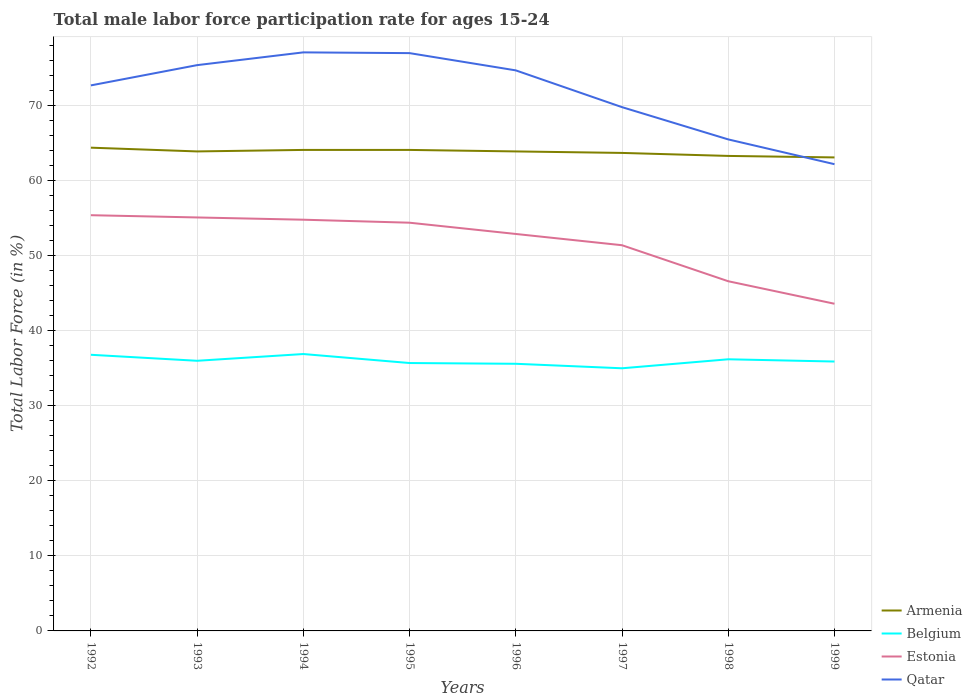Is the number of lines equal to the number of legend labels?
Your answer should be very brief. Yes. Across all years, what is the maximum male labor force participation rate in Armenia?
Your response must be concise. 63.1. In which year was the male labor force participation rate in Armenia maximum?
Offer a terse response. 1999. What is the total male labor force participation rate in Armenia in the graph?
Ensure brevity in your answer.  1. What is the difference between the highest and the second highest male labor force participation rate in Estonia?
Make the answer very short. 11.8. What is the difference between the highest and the lowest male labor force participation rate in Belgium?
Give a very brief answer. 3. Is the male labor force participation rate in Estonia strictly greater than the male labor force participation rate in Armenia over the years?
Offer a very short reply. Yes. What is the difference between two consecutive major ticks on the Y-axis?
Offer a terse response. 10. Are the values on the major ticks of Y-axis written in scientific E-notation?
Give a very brief answer. No. Where does the legend appear in the graph?
Provide a succinct answer. Bottom right. How many legend labels are there?
Provide a short and direct response. 4. How are the legend labels stacked?
Your answer should be very brief. Vertical. What is the title of the graph?
Make the answer very short. Total male labor force participation rate for ages 15-24. Does "United Kingdom" appear as one of the legend labels in the graph?
Keep it short and to the point. No. What is the label or title of the X-axis?
Offer a very short reply. Years. What is the label or title of the Y-axis?
Your answer should be compact. Total Labor Force (in %). What is the Total Labor Force (in %) in Armenia in 1992?
Your answer should be compact. 64.4. What is the Total Labor Force (in %) in Belgium in 1992?
Provide a succinct answer. 36.8. What is the Total Labor Force (in %) in Estonia in 1992?
Provide a succinct answer. 55.4. What is the Total Labor Force (in %) in Qatar in 1992?
Your answer should be very brief. 72.7. What is the Total Labor Force (in %) of Armenia in 1993?
Ensure brevity in your answer.  63.9. What is the Total Labor Force (in %) in Estonia in 1993?
Ensure brevity in your answer.  55.1. What is the Total Labor Force (in %) in Qatar in 1993?
Give a very brief answer. 75.4. What is the Total Labor Force (in %) in Armenia in 1994?
Offer a terse response. 64.1. What is the Total Labor Force (in %) of Belgium in 1994?
Your response must be concise. 36.9. What is the Total Labor Force (in %) of Estonia in 1994?
Give a very brief answer. 54.8. What is the Total Labor Force (in %) in Qatar in 1994?
Provide a succinct answer. 77.1. What is the Total Labor Force (in %) of Armenia in 1995?
Keep it short and to the point. 64.1. What is the Total Labor Force (in %) of Belgium in 1995?
Your response must be concise. 35.7. What is the Total Labor Force (in %) in Estonia in 1995?
Provide a succinct answer. 54.4. What is the Total Labor Force (in %) of Armenia in 1996?
Your answer should be very brief. 63.9. What is the Total Labor Force (in %) in Belgium in 1996?
Your answer should be very brief. 35.6. What is the Total Labor Force (in %) of Estonia in 1996?
Make the answer very short. 52.9. What is the Total Labor Force (in %) of Qatar in 1996?
Provide a short and direct response. 74.7. What is the Total Labor Force (in %) in Armenia in 1997?
Your answer should be compact. 63.7. What is the Total Labor Force (in %) of Belgium in 1997?
Your answer should be compact. 35. What is the Total Labor Force (in %) of Estonia in 1997?
Provide a succinct answer. 51.4. What is the Total Labor Force (in %) in Qatar in 1997?
Offer a terse response. 69.8. What is the Total Labor Force (in %) of Armenia in 1998?
Offer a terse response. 63.3. What is the Total Labor Force (in %) in Belgium in 1998?
Make the answer very short. 36.2. What is the Total Labor Force (in %) in Estonia in 1998?
Ensure brevity in your answer.  46.6. What is the Total Labor Force (in %) in Qatar in 1998?
Provide a succinct answer. 65.5. What is the Total Labor Force (in %) in Armenia in 1999?
Offer a terse response. 63.1. What is the Total Labor Force (in %) in Belgium in 1999?
Offer a very short reply. 35.9. What is the Total Labor Force (in %) in Estonia in 1999?
Keep it short and to the point. 43.6. What is the Total Labor Force (in %) of Qatar in 1999?
Your response must be concise. 62.2. Across all years, what is the maximum Total Labor Force (in %) in Armenia?
Your answer should be compact. 64.4. Across all years, what is the maximum Total Labor Force (in %) in Belgium?
Provide a succinct answer. 36.9. Across all years, what is the maximum Total Labor Force (in %) of Estonia?
Offer a terse response. 55.4. Across all years, what is the maximum Total Labor Force (in %) in Qatar?
Provide a succinct answer. 77.1. Across all years, what is the minimum Total Labor Force (in %) in Armenia?
Provide a short and direct response. 63.1. Across all years, what is the minimum Total Labor Force (in %) of Belgium?
Provide a succinct answer. 35. Across all years, what is the minimum Total Labor Force (in %) of Estonia?
Make the answer very short. 43.6. Across all years, what is the minimum Total Labor Force (in %) of Qatar?
Your response must be concise. 62.2. What is the total Total Labor Force (in %) in Armenia in the graph?
Make the answer very short. 510.5. What is the total Total Labor Force (in %) in Belgium in the graph?
Your answer should be compact. 288.1. What is the total Total Labor Force (in %) in Estonia in the graph?
Offer a very short reply. 414.2. What is the total Total Labor Force (in %) of Qatar in the graph?
Your response must be concise. 574.4. What is the difference between the Total Labor Force (in %) of Armenia in 1992 and that in 1993?
Your answer should be compact. 0.5. What is the difference between the Total Labor Force (in %) in Estonia in 1992 and that in 1993?
Offer a very short reply. 0.3. What is the difference between the Total Labor Force (in %) in Qatar in 1992 and that in 1993?
Offer a terse response. -2.7. What is the difference between the Total Labor Force (in %) in Qatar in 1992 and that in 1994?
Ensure brevity in your answer.  -4.4. What is the difference between the Total Labor Force (in %) of Estonia in 1992 and that in 1995?
Give a very brief answer. 1. What is the difference between the Total Labor Force (in %) of Belgium in 1992 and that in 1996?
Your answer should be very brief. 1.2. What is the difference between the Total Labor Force (in %) in Armenia in 1992 and that in 1997?
Offer a terse response. 0.7. What is the difference between the Total Labor Force (in %) in Belgium in 1992 and that in 1997?
Provide a succinct answer. 1.8. What is the difference between the Total Labor Force (in %) in Estonia in 1992 and that in 1997?
Give a very brief answer. 4. What is the difference between the Total Labor Force (in %) of Armenia in 1992 and that in 1998?
Your response must be concise. 1.1. What is the difference between the Total Labor Force (in %) of Belgium in 1992 and that in 1998?
Provide a short and direct response. 0.6. What is the difference between the Total Labor Force (in %) of Estonia in 1992 and that in 1998?
Offer a terse response. 8.8. What is the difference between the Total Labor Force (in %) of Qatar in 1992 and that in 1998?
Keep it short and to the point. 7.2. What is the difference between the Total Labor Force (in %) in Armenia in 1992 and that in 1999?
Your answer should be very brief. 1.3. What is the difference between the Total Labor Force (in %) of Belgium in 1992 and that in 1999?
Give a very brief answer. 0.9. What is the difference between the Total Labor Force (in %) in Estonia in 1992 and that in 1999?
Your answer should be very brief. 11.8. What is the difference between the Total Labor Force (in %) in Belgium in 1993 and that in 1994?
Give a very brief answer. -0.9. What is the difference between the Total Labor Force (in %) in Estonia in 1993 and that in 1994?
Offer a terse response. 0.3. What is the difference between the Total Labor Force (in %) of Armenia in 1993 and that in 1995?
Your answer should be very brief. -0.2. What is the difference between the Total Labor Force (in %) of Estonia in 1993 and that in 1995?
Give a very brief answer. 0.7. What is the difference between the Total Labor Force (in %) of Qatar in 1993 and that in 1995?
Ensure brevity in your answer.  -1.6. What is the difference between the Total Labor Force (in %) of Belgium in 1993 and that in 1996?
Ensure brevity in your answer.  0.4. What is the difference between the Total Labor Force (in %) in Estonia in 1993 and that in 1996?
Give a very brief answer. 2.2. What is the difference between the Total Labor Force (in %) in Estonia in 1993 and that in 1997?
Keep it short and to the point. 3.7. What is the difference between the Total Labor Force (in %) in Belgium in 1993 and that in 1998?
Your response must be concise. -0.2. What is the difference between the Total Labor Force (in %) of Estonia in 1993 and that in 1998?
Your answer should be compact. 8.5. What is the difference between the Total Labor Force (in %) in Qatar in 1993 and that in 1998?
Keep it short and to the point. 9.9. What is the difference between the Total Labor Force (in %) in Armenia in 1993 and that in 1999?
Give a very brief answer. 0.8. What is the difference between the Total Labor Force (in %) in Armenia in 1994 and that in 1995?
Keep it short and to the point. 0. What is the difference between the Total Labor Force (in %) in Armenia in 1994 and that in 1996?
Offer a very short reply. 0.2. What is the difference between the Total Labor Force (in %) in Estonia in 1994 and that in 1996?
Ensure brevity in your answer.  1.9. What is the difference between the Total Labor Force (in %) in Estonia in 1994 and that in 1997?
Provide a succinct answer. 3.4. What is the difference between the Total Labor Force (in %) in Qatar in 1994 and that in 1997?
Give a very brief answer. 7.3. What is the difference between the Total Labor Force (in %) of Armenia in 1994 and that in 1998?
Offer a terse response. 0.8. What is the difference between the Total Labor Force (in %) in Armenia in 1994 and that in 1999?
Ensure brevity in your answer.  1. What is the difference between the Total Labor Force (in %) of Estonia in 1994 and that in 1999?
Your answer should be very brief. 11.2. What is the difference between the Total Labor Force (in %) of Belgium in 1995 and that in 1996?
Make the answer very short. 0.1. What is the difference between the Total Labor Force (in %) of Armenia in 1995 and that in 1997?
Offer a very short reply. 0.4. What is the difference between the Total Labor Force (in %) of Estonia in 1995 and that in 1997?
Keep it short and to the point. 3. What is the difference between the Total Labor Force (in %) of Armenia in 1995 and that in 1998?
Ensure brevity in your answer.  0.8. What is the difference between the Total Labor Force (in %) in Belgium in 1995 and that in 1998?
Provide a short and direct response. -0.5. What is the difference between the Total Labor Force (in %) in Estonia in 1995 and that in 1998?
Ensure brevity in your answer.  7.8. What is the difference between the Total Labor Force (in %) of Armenia in 1995 and that in 1999?
Provide a short and direct response. 1. What is the difference between the Total Labor Force (in %) in Estonia in 1995 and that in 1999?
Provide a succinct answer. 10.8. What is the difference between the Total Labor Force (in %) of Armenia in 1996 and that in 1997?
Offer a terse response. 0.2. What is the difference between the Total Labor Force (in %) of Estonia in 1996 and that in 1997?
Make the answer very short. 1.5. What is the difference between the Total Labor Force (in %) of Armenia in 1996 and that in 1998?
Ensure brevity in your answer.  0.6. What is the difference between the Total Labor Force (in %) in Belgium in 1996 and that in 1998?
Offer a very short reply. -0.6. What is the difference between the Total Labor Force (in %) in Armenia in 1996 and that in 1999?
Ensure brevity in your answer.  0.8. What is the difference between the Total Labor Force (in %) in Qatar in 1997 and that in 1998?
Provide a short and direct response. 4.3. What is the difference between the Total Labor Force (in %) of Armenia in 1997 and that in 1999?
Give a very brief answer. 0.6. What is the difference between the Total Labor Force (in %) of Belgium in 1997 and that in 1999?
Offer a very short reply. -0.9. What is the difference between the Total Labor Force (in %) in Qatar in 1997 and that in 1999?
Your response must be concise. 7.6. What is the difference between the Total Labor Force (in %) of Estonia in 1998 and that in 1999?
Provide a succinct answer. 3. What is the difference between the Total Labor Force (in %) of Armenia in 1992 and the Total Labor Force (in %) of Belgium in 1993?
Provide a short and direct response. 28.4. What is the difference between the Total Labor Force (in %) in Belgium in 1992 and the Total Labor Force (in %) in Estonia in 1993?
Your answer should be very brief. -18.3. What is the difference between the Total Labor Force (in %) in Belgium in 1992 and the Total Labor Force (in %) in Qatar in 1993?
Your response must be concise. -38.6. What is the difference between the Total Labor Force (in %) in Estonia in 1992 and the Total Labor Force (in %) in Qatar in 1993?
Your response must be concise. -20. What is the difference between the Total Labor Force (in %) of Armenia in 1992 and the Total Labor Force (in %) of Estonia in 1994?
Your answer should be compact. 9.6. What is the difference between the Total Labor Force (in %) of Armenia in 1992 and the Total Labor Force (in %) of Qatar in 1994?
Ensure brevity in your answer.  -12.7. What is the difference between the Total Labor Force (in %) in Belgium in 1992 and the Total Labor Force (in %) in Estonia in 1994?
Your answer should be very brief. -18. What is the difference between the Total Labor Force (in %) in Belgium in 1992 and the Total Labor Force (in %) in Qatar in 1994?
Make the answer very short. -40.3. What is the difference between the Total Labor Force (in %) of Estonia in 1992 and the Total Labor Force (in %) of Qatar in 1994?
Give a very brief answer. -21.7. What is the difference between the Total Labor Force (in %) of Armenia in 1992 and the Total Labor Force (in %) of Belgium in 1995?
Provide a succinct answer. 28.7. What is the difference between the Total Labor Force (in %) in Armenia in 1992 and the Total Labor Force (in %) in Estonia in 1995?
Your answer should be very brief. 10. What is the difference between the Total Labor Force (in %) in Belgium in 1992 and the Total Labor Force (in %) in Estonia in 1995?
Your response must be concise. -17.6. What is the difference between the Total Labor Force (in %) in Belgium in 1992 and the Total Labor Force (in %) in Qatar in 1995?
Ensure brevity in your answer.  -40.2. What is the difference between the Total Labor Force (in %) in Estonia in 1992 and the Total Labor Force (in %) in Qatar in 1995?
Provide a short and direct response. -21.6. What is the difference between the Total Labor Force (in %) in Armenia in 1992 and the Total Labor Force (in %) in Belgium in 1996?
Your response must be concise. 28.8. What is the difference between the Total Labor Force (in %) of Armenia in 1992 and the Total Labor Force (in %) of Qatar in 1996?
Ensure brevity in your answer.  -10.3. What is the difference between the Total Labor Force (in %) in Belgium in 1992 and the Total Labor Force (in %) in Estonia in 1996?
Provide a short and direct response. -16.1. What is the difference between the Total Labor Force (in %) of Belgium in 1992 and the Total Labor Force (in %) of Qatar in 1996?
Your response must be concise. -37.9. What is the difference between the Total Labor Force (in %) in Estonia in 1992 and the Total Labor Force (in %) in Qatar in 1996?
Make the answer very short. -19.3. What is the difference between the Total Labor Force (in %) in Armenia in 1992 and the Total Labor Force (in %) in Belgium in 1997?
Keep it short and to the point. 29.4. What is the difference between the Total Labor Force (in %) of Armenia in 1992 and the Total Labor Force (in %) of Qatar in 1997?
Your response must be concise. -5.4. What is the difference between the Total Labor Force (in %) in Belgium in 1992 and the Total Labor Force (in %) in Estonia in 1997?
Offer a terse response. -14.6. What is the difference between the Total Labor Force (in %) of Belgium in 1992 and the Total Labor Force (in %) of Qatar in 1997?
Keep it short and to the point. -33. What is the difference between the Total Labor Force (in %) in Estonia in 1992 and the Total Labor Force (in %) in Qatar in 1997?
Provide a short and direct response. -14.4. What is the difference between the Total Labor Force (in %) of Armenia in 1992 and the Total Labor Force (in %) of Belgium in 1998?
Provide a short and direct response. 28.2. What is the difference between the Total Labor Force (in %) of Armenia in 1992 and the Total Labor Force (in %) of Estonia in 1998?
Your response must be concise. 17.8. What is the difference between the Total Labor Force (in %) of Belgium in 1992 and the Total Labor Force (in %) of Qatar in 1998?
Your response must be concise. -28.7. What is the difference between the Total Labor Force (in %) in Estonia in 1992 and the Total Labor Force (in %) in Qatar in 1998?
Your answer should be very brief. -10.1. What is the difference between the Total Labor Force (in %) of Armenia in 1992 and the Total Labor Force (in %) of Estonia in 1999?
Your answer should be very brief. 20.8. What is the difference between the Total Labor Force (in %) in Belgium in 1992 and the Total Labor Force (in %) in Estonia in 1999?
Your response must be concise. -6.8. What is the difference between the Total Labor Force (in %) in Belgium in 1992 and the Total Labor Force (in %) in Qatar in 1999?
Provide a succinct answer. -25.4. What is the difference between the Total Labor Force (in %) in Armenia in 1993 and the Total Labor Force (in %) in Estonia in 1994?
Give a very brief answer. 9.1. What is the difference between the Total Labor Force (in %) of Belgium in 1993 and the Total Labor Force (in %) of Estonia in 1994?
Make the answer very short. -18.8. What is the difference between the Total Labor Force (in %) of Belgium in 1993 and the Total Labor Force (in %) of Qatar in 1994?
Provide a succinct answer. -41.1. What is the difference between the Total Labor Force (in %) in Armenia in 1993 and the Total Labor Force (in %) in Belgium in 1995?
Provide a short and direct response. 28.2. What is the difference between the Total Labor Force (in %) of Belgium in 1993 and the Total Labor Force (in %) of Estonia in 1995?
Offer a very short reply. -18.4. What is the difference between the Total Labor Force (in %) in Belgium in 1993 and the Total Labor Force (in %) in Qatar in 1995?
Ensure brevity in your answer.  -41. What is the difference between the Total Labor Force (in %) in Estonia in 1993 and the Total Labor Force (in %) in Qatar in 1995?
Your response must be concise. -21.9. What is the difference between the Total Labor Force (in %) in Armenia in 1993 and the Total Labor Force (in %) in Belgium in 1996?
Offer a terse response. 28.3. What is the difference between the Total Labor Force (in %) of Belgium in 1993 and the Total Labor Force (in %) of Estonia in 1996?
Your answer should be very brief. -16.9. What is the difference between the Total Labor Force (in %) in Belgium in 1993 and the Total Labor Force (in %) in Qatar in 1996?
Make the answer very short. -38.7. What is the difference between the Total Labor Force (in %) of Estonia in 1993 and the Total Labor Force (in %) of Qatar in 1996?
Ensure brevity in your answer.  -19.6. What is the difference between the Total Labor Force (in %) of Armenia in 1993 and the Total Labor Force (in %) of Belgium in 1997?
Offer a very short reply. 28.9. What is the difference between the Total Labor Force (in %) of Belgium in 1993 and the Total Labor Force (in %) of Estonia in 1997?
Offer a very short reply. -15.4. What is the difference between the Total Labor Force (in %) of Belgium in 1993 and the Total Labor Force (in %) of Qatar in 1997?
Provide a short and direct response. -33.8. What is the difference between the Total Labor Force (in %) of Estonia in 1993 and the Total Labor Force (in %) of Qatar in 1997?
Give a very brief answer. -14.7. What is the difference between the Total Labor Force (in %) in Armenia in 1993 and the Total Labor Force (in %) in Belgium in 1998?
Your answer should be compact. 27.7. What is the difference between the Total Labor Force (in %) of Armenia in 1993 and the Total Labor Force (in %) of Estonia in 1998?
Keep it short and to the point. 17.3. What is the difference between the Total Labor Force (in %) of Belgium in 1993 and the Total Labor Force (in %) of Qatar in 1998?
Offer a terse response. -29.5. What is the difference between the Total Labor Force (in %) of Estonia in 1993 and the Total Labor Force (in %) of Qatar in 1998?
Provide a short and direct response. -10.4. What is the difference between the Total Labor Force (in %) of Armenia in 1993 and the Total Labor Force (in %) of Estonia in 1999?
Provide a short and direct response. 20.3. What is the difference between the Total Labor Force (in %) in Armenia in 1993 and the Total Labor Force (in %) in Qatar in 1999?
Provide a short and direct response. 1.7. What is the difference between the Total Labor Force (in %) of Belgium in 1993 and the Total Labor Force (in %) of Qatar in 1999?
Provide a succinct answer. -26.2. What is the difference between the Total Labor Force (in %) in Estonia in 1993 and the Total Labor Force (in %) in Qatar in 1999?
Provide a short and direct response. -7.1. What is the difference between the Total Labor Force (in %) in Armenia in 1994 and the Total Labor Force (in %) in Belgium in 1995?
Your response must be concise. 28.4. What is the difference between the Total Labor Force (in %) of Armenia in 1994 and the Total Labor Force (in %) of Qatar in 1995?
Your response must be concise. -12.9. What is the difference between the Total Labor Force (in %) of Belgium in 1994 and the Total Labor Force (in %) of Estonia in 1995?
Offer a terse response. -17.5. What is the difference between the Total Labor Force (in %) in Belgium in 1994 and the Total Labor Force (in %) in Qatar in 1995?
Keep it short and to the point. -40.1. What is the difference between the Total Labor Force (in %) of Estonia in 1994 and the Total Labor Force (in %) of Qatar in 1995?
Provide a short and direct response. -22.2. What is the difference between the Total Labor Force (in %) in Armenia in 1994 and the Total Labor Force (in %) in Estonia in 1996?
Your response must be concise. 11.2. What is the difference between the Total Labor Force (in %) in Armenia in 1994 and the Total Labor Force (in %) in Qatar in 1996?
Offer a terse response. -10.6. What is the difference between the Total Labor Force (in %) of Belgium in 1994 and the Total Labor Force (in %) of Qatar in 1996?
Give a very brief answer. -37.8. What is the difference between the Total Labor Force (in %) in Estonia in 1994 and the Total Labor Force (in %) in Qatar in 1996?
Make the answer very short. -19.9. What is the difference between the Total Labor Force (in %) of Armenia in 1994 and the Total Labor Force (in %) of Belgium in 1997?
Offer a terse response. 29.1. What is the difference between the Total Labor Force (in %) of Armenia in 1994 and the Total Labor Force (in %) of Estonia in 1997?
Provide a short and direct response. 12.7. What is the difference between the Total Labor Force (in %) in Armenia in 1994 and the Total Labor Force (in %) in Qatar in 1997?
Provide a succinct answer. -5.7. What is the difference between the Total Labor Force (in %) in Belgium in 1994 and the Total Labor Force (in %) in Qatar in 1997?
Ensure brevity in your answer.  -32.9. What is the difference between the Total Labor Force (in %) in Estonia in 1994 and the Total Labor Force (in %) in Qatar in 1997?
Provide a short and direct response. -15. What is the difference between the Total Labor Force (in %) in Armenia in 1994 and the Total Labor Force (in %) in Belgium in 1998?
Ensure brevity in your answer.  27.9. What is the difference between the Total Labor Force (in %) of Armenia in 1994 and the Total Labor Force (in %) of Estonia in 1998?
Keep it short and to the point. 17.5. What is the difference between the Total Labor Force (in %) of Armenia in 1994 and the Total Labor Force (in %) of Qatar in 1998?
Ensure brevity in your answer.  -1.4. What is the difference between the Total Labor Force (in %) in Belgium in 1994 and the Total Labor Force (in %) in Qatar in 1998?
Your response must be concise. -28.6. What is the difference between the Total Labor Force (in %) of Armenia in 1994 and the Total Labor Force (in %) of Belgium in 1999?
Offer a terse response. 28.2. What is the difference between the Total Labor Force (in %) of Armenia in 1994 and the Total Labor Force (in %) of Qatar in 1999?
Make the answer very short. 1.9. What is the difference between the Total Labor Force (in %) in Belgium in 1994 and the Total Labor Force (in %) in Estonia in 1999?
Your answer should be compact. -6.7. What is the difference between the Total Labor Force (in %) of Belgium in 1994 and the Total Labor Force (in %) of Qatar in 1999?
Give a very brief answer. -25.3. What is the difference between the Total Labor Force (in %) of Armenia in 1995 and the Total Labor Force (in %) of Belgium in 1996?
Your response must be concise. 28.5. What is the difference between the Total Labor Force (in %) in Armenia in 1995 and the Total Labor Force (in %) in Qatar in 1996?
Offer a very short reply. -10.6. What is the difference between the Total Labor Force (in %) of Belgium in 1995 and the Total Labor Force (in %) of Estonia in 1996?
Offer a terse response. -17.2. What is the difference between the Total Labor Force (in %) of Belgium in 1995 and the Total Labor Force (in %) of Qatar in 1996?
Offer a very short reply. -39. What is the difference between the Total Labor Force (in %) of Estonia in 1995 and the Total Labor Force (in %) of Qatar in 1996?
Make the answer very short. -20.3. What is the difference between the Total Labor Force (in %) of Armenia in 1995 and the Total Labor Force (in %) of Belgium in 1997?
Keep it short and to the point. 29.1. What is the difference between the Total Labor Force (in %) in Armenia in 1995 and the Total Labor Force (in %) in Estonia in 1997?
Keep it short and to the point. 12.7. What is the difference between the Total Labor Force (in %) in Belgium in 1995 and the Total Labor Force (in %) in Estonia in 1997?
Give a very brief answer. -15.7. What is the difference between the Total Labor Force (in %) of Belgium in 1995 and the Total Labor Force (in %) of Qatar in 1997?
Your answer should be compact. -34.1. What is the difference between the Total Labor Force (in %) in Estonia in 1995 and the Total Labor Force (in %) in Qatar in 1997?
Keep it short and to the point. -15.4. What is the difference between the Total Labor Force (in %) of Armenia in 1995 and the Total Labor Force (in %) of Belgium in 1998?
Give a very brief answer. 27.9. What is the difference between the Total Labor Force (in %) in Armenia in 1995 and the Total Labor Force (in %) in Qatar in 1998?
Ensure brevity in your answer.  -1.4. What is the difference between the Total Labor Force (in %) of Belgium in 1995 and the Total Labor Force (in %) of Estonia in 1998?
Your response must be concise. -10.9. What is the difference between the Total Labor Force (in %) in Belgium in 1995 and the Total Labor Force (in %) in Qatar in 1998?
Provide a succinct answer. -29.8. What is the difference between the Total Labor Force (in %) of Armenia in 1995 and the Total Labor Force (in %) of Belgium in 1999?
Offer a very short reply. 28.2. What is the difference between the Total Labor Force (in %) of Armenia in 1995 and the Total Labor Force (in %) of Estonia in 1999?
Make the answer very short. 20.5. What is the difference between the Total Labor Force (in %) in Belgium in 1995 and the Total Labor Force (in %) in Estonia in 1999?
Offer a very short reply. -7.9. What is the difference between the Total Labor Force (in %) in Belgium in 1995 and the Total Labor Force (in %) in Qatar in 1999?
Offer a very short reply. -26.5. What is the difference between the Total Labor Force (in %) in Armenia in 1996 and the Total Labor Force (in %) in Belgium in 1997?
Provide a short and direct response. 28.9. What is the difference between the Total Labor Force (in %) in Armenia in 1996 and the Total Labor Force (in %) in Estonia in 1997?
Your answer should be very brief. 12.5. What is the difference between the Total Labor Force (in %) of Belgium in 1996 and the Total Labor Force (in %) of Estonia in 1997?
Offer a very short reply. -15.8. What is the difference between the Total Labor Force (in %) of Belgium in 1996 and the Total Labor Force (in %) of Qatar in 1997?
Offer a very short reply. -34.2. What is the difference between the Total Labor Force (in %) in Estonia in 1996 and the Total Labor Force (in %) in Qatar in 1997?
Ensure brevity in your answer.  -16.9. What is the difference between the Total Labor Force (in %) in Armenia in 1996 and the Total Labor Force (in %) in Belgium in 1998?
Give a very brief answer. 27.7. What is the difference between the Total Labor Force (in %) in Armenia in 1996 and the Total Labor Force (in %) in Qatar in 1998?
Provide a short and direct response. -1.6. What is the difference between the Total Labor Force (in %) of Belgium in 1996 and the Total Labor Force (in %) of Qatar in 1998?
Your answer should be very brief. -29.9. What is the difference between the Total Labor Force (in %) in Armenia in 1996 and the Total Labor Force (in %) in Estonia in 1999?
Provide a succinct answer. 20.3. What is the difference between the Total Labor Force (in %) of Belgium in 1996 and the Total Labor Force (in %) of Qatar in 1999?
Provide a short and direct response. -26.6. What is the difference between the Total Labor Force (in %) in Armenia in 1997 and the Total Labor Force (in %) in Belgium in 1998?
Give a very brief answer. 27.5. What is the difference between the Total Labor Force (in %) in Armenia in 1997 and the Total Labor Force (in %) in Estonia in 1998?
Your response must be concise. 17.1. What is the difference between the Total Labor Force (in %) in Armenia in 1997 and the Total Labor Force (in %) in Qatar in 1998?
Your answer should be very brief. -1.8. What is the difference between the Total Labor Force (in %) of Belgium in 1997 and the Total Labor Force (in %) of Estonia in 1998?
Your answer should be very brief. -11.6. What is the difference between the Total Labor Force (in %) in Belgium in 1997 and the Total Labor Force (in %) in Qatar in 1998?
Make the answer very short. -30.5. What is the difference between the Total Labor Force (in %) in Estonia in 1997 and the Total Labor Force (in %) in Qatar in 1998?
Offer a terse response. -14.1. What is the difference between the Total Labor Force (in %) in Armenia in 1997 and the Total Labor Force (in %) in Belgium in 1999?
Your answer should be very brief. 27.8. What is the difference between the Total Labor Force (in %) in Armenia in 1997 and the Total Labor Force (in %) in Estonia in 1999?
Provide a short and direct response. 20.1. What is the difference between the Total Labor Force (in %) in Belgium in 1997 and the Total Labor Force (in %) in Qatar in 1999?
Make the answer very short. -27.2. What is the difference between the Total Labor Force (in %) of Estonia in 1997 and the Total Labor Force (in %) of Qatar in 1999?
Ensure brevity in your answer.  -10.8. What is the difference between the Total Labor Force (in %) in Armenia in 1998 and the Total Labor Force (in %) in Belgium in 1999?
Give a very brief answer. 27.4. What is the difference between the Total Labor Force (in %) of Armenia in 1998 and the Total Labor Force (in %) of Qatar in 1999?
Offer a terse response. 1.1. What is the difference between the Total Labor Force (in %) in Estonia in 1998 and the Total Labor Force (in %) in Qatar in 1999?
Your answer should be very brief. -15.6. What is the average Total Labor Force (in %) of Armenia per year?
Provide a succinct answer. 63.81. What is the average Total Labor Force (in %) in Belgium per year?
Keep it short and to the point. 36.01. What is the average Total Labor Force (in %) of Estonia per year?
Your answer should be very brief. 51.77. What is the average Total Labor Force (in %) in Qatar per year?
Your answer should be very brief. 71.8. In the year 1992, what is the difference between the Total Labor Force (in %) of Armenia and Total Labor Force (in %) of Belgium?
Offer a very short reply. 27.6. In the year 1992, what is the difference between the Total Labor Force (in %) in Belgium and Total Labor Force (in %) in Estonia?
Make the answer very short. -18.6. In the year 1992, what is the difference between the Total Labor Force (in %) in Belgium and Total Labor Force (in %) in Qatar?
Your answer should be very brief. -35.9. In the year 1992, what is the difference between the Total Labor Force (in %) of Estonia and Total Labor Force (in %) of Qatar?
Your answer should be very brief. -17.3. In the year 1993, what is the difference between the Total Labor Force (in %) in Armenia and Total Labor Force (in %) in Belgium?
Give a very brief answer. 27.9. In the year 1993, what is the difference between the Total Labor Force (in %) of Belgium and Total Labor Force (in %) of Estonia?
Your answer should be compact. -19.1. In the year 1993, what is the difference between the Total Labor Force (in %) of Belgium and Total Labor Force (in %) of Qatar?
Provide a succinct answer. -39.4. In the year 1993, what is the difference between the Total Labor Force (in %) of Estonia and Total Labor Force (in %) of Qatar?
Make the answer very short. -20.3. In the year 1994, what is the difference between the Total Labor Force (in %) in Armenia and Total Labor Force (in %) in Belgium?
Offer a terse response. 27.2. In the year 1994, what is the difference between the Total Labor Force (in %) in Armenia and Total Labor Force (in %) in Qatar?
Your response must be concise. -13. In the year 1994, what is the difference between the Total Labor Force (in %) in Belgium and Total Labor Force (in %) in Estonia?
Ensure brevity in your answer.  -17.9. In the year 1994, what is the difference between the Total Labor Force (in %) of Belgium and Total Labor Force (in %) of Qatar?
Make the answer very short. -40.2. In the year 1994, what is the difference between the Total Labor Force (in %) of Estonia and Total Labor Force (in %) of Qatar?
Your answer should be compact. -22.3. In the year 1995, what is the difference between the Total Labor Force (in %) in Armenia and Total Labor Force (in %) in Belgium?
Give a very brief answer. 28.4. In the year 1995, what is the difference between the Total Labor Force (in %) of Armenia and Total Labor Force (in %) of Estonia?
Your answer should be very brief. 9.7. In the year 1995, what is the difference between the Total Labor Force (in %) in Armenia and Total Labor Force (in %) in Qatar?
Keep it short and to the point. -12.9. In the year 1995, what is the difference between the Total Labor Force (in %) in Belgium and Total Labor Force (in %) in Estonia?
Your answer should be compact. -18.7. In the year 1995, what is the difference between the Total Labor Force (in %) of Belgium and Total Labor Force (in %) of Qatar?
Offer a terse response. -41.3. In the year 1995, what is the difference between the Total Labor Force (in %) in Estonia and Total Labor Force (in %) in Qatar?
Your answer should be very brief. -22.6. In the year 1996, what is the difference between the Total Labor Force (in %) in Armenia and Total Labor Force (in %) in Belgium?
Ensure brevity in your answer.  28.3. In the year 1996, what is the difference between the Total Labor Force (in %) in Armenia and Total Labor Force (in %) in Qatar?
Offer a terse response. -10.8. In the year 1996, what is the difference between the Total Labor Force (in %) of Belgium and Total Labor Force (in %) of Estonia?
Your response must be concise. -17.3. In the year 1996, what is the difference between the Total Labor Force (in %) of Belgium and Total Labor Force (in %) of Qatar?
Ensure brevity in your answer.  -39.1. In the year 1996, what is the difference between the Total Labor Force (in %) in Estonia and Total Labor Force (in %) in Qatar?
Your answer should be compact. -21.8. In the year 1997, what is the difference between the Total Labor Force (in %) in Armenia and Total Labor Force (in %) in Belgium?
Provide a succinct answer. 28.7. In the year 1997, what is the difference between the Total Labor Force (in %) in Armenia and Total Labor Force (in %) in Estonia?
Offer a terse response. 12.3. In the year 1997, what is the difference between the Total Labor Force (in %) in Armenia and Total Labor Force (in %) in Qatar?
Your response must be concise. -6.1. In the year 1997, what is the difference between the Total Labor Force (in %) in Belgium and Total Labor Force (in %) in Estonia?
Offer a very short reply. -16.4. In the year 1997, what is the difference between the Total Labor Force (in %) of Belgium and Total Labor Force (in %) of Qatar?
Your answer should be very brief. -34.8. In the year 1997, what is the difference between the Total Labor Force (in %) of Estonia and Total Labor Force (in %) of Qatar?
Give a very brief answer. -18.4. In the year 1998, what is the difference between the Total Labor Force (in %) of Armenia and Total Labor Force (in %) of Belgium?
Keep it short and to the point. 27.1. In the year 1998, what is the difference between the Total Labor Force (in %) in Belgium and Total Labor Force (in %) in Estonia?
Keep it short and to the point. -10.4. In the year 1998, what is the difference between the Total Labor Force (in %) of Belgium and Total Labor Force (in %) of Qatar?
Give a very brief answer. -29.3. In the year 1998, what is the difference between the Total Labor Force (in %) of Estonia and Total Labor Force (in %) of Qatar?
Offer a very short reply. -18.9. In the year 1999, what is the difference between the Total Labor Force (in %) of Armenia and Total Labor Force (in %) of Belgium?
Your answer should be compact. 27.2. In the year 1999, what is the difference between the Total Labor Force (in %) of Armenia and Total Labor Force (in %) of Estonia?
Your answer should be compact. 19.5. In the year 1999, what is the difference between the Total Labor Force (in %) in Armenia and Total Labor Force (in %) in Qatar?
Keep it short and to the point. 0.9. In the year 1999, what is the difference between the Total Labor Force (in %) in Belgium and Total Labor Force (in %) in Qatar?
Ensure brevity in your answer.  -26.3. In the year 1999, what is the difference between the Total Labor Force (in %) in Estonia and Total Labor Force (in %) in Qatar?
Keep it short and to the point. -18.6. What is the ratio of the Total Labor Force (in %) in Armenia in 1992 to that in 1993?
Give a very brief answer. 1.01. What is the ratio of the Total Labor Force (in %) in Belgium in 1992 to that in 1993?
Offer a terse response. 1.02. What is the ratio of the Total Labor Force (in %) of Estonia in 1992 to that in 1993?
Your answer should be very brief. 1.01. What is the ratio of the Total Labor Force (in %) in Qatar in 1992 to that in 1993?
Offer a terse response. 0.96. What is the ratio of the Total Labor Force (in %) in Belgium in 1992 to that in 1994?
Offer a very short reply. 1. What is the ratio of the Total Labor Force (in %) in Estonia in 1992 to that in 1994?
Keep it short and to the point. 1.01. What is the ratio of the Total Labor Force (in %) of Qatar in 1992 to that in 1994?
Provide a succinct answer. 0.94. What is the ratio of the Total Labor Force (in %) of Belgium in 1992 to that in 1995?
Provide a short and direct response. 1.03. What is the ratio of the Total Labor Force (in %) of Estonia in 1992 to that in 1995?
Offer a terse response. 1.02. What is the ratio of the Total Labor Force (in %) in Qatar in 1992 to that in 1995?
Offer a terse response. 0.94. What is the ratio of the Total Labor Force (in %) in Belgium in 1992 to that in 1996?
Provide a succinct answer. 1.03. What is the ratio of the Total Labor Force (in %) of Estonia in 1992 to that in 1996?
Give a very brief answer. 1.05. What is the ratio of the Total Labor Force (in %) of Qatar in 1992 to that in 1996?
Ensure brevity in your answer.  0.97. What is the ratio of the Total Labor Force (in %) in Armenia in 1992 to that in 1997?
Offer a terse response. 1.01. What is the ratio of the Total Labor Force (in %) in Belgium in 1992 to that in 1997?
Keep it short and to the point. 1.05. What is the ratio of the Total Labor Force (in %) in Estonia in 1992 to that in 1997?
Ensure brevity in your answer.  1.08. What is the ratio of the Total Labor Force (in %) of Qatar in 1992 to that in 1997?
Keep it short and to the point. 1.04. What is the ratio of the Total Labor Force (in %) of Armenia in 1992 to that in 1998?
Offer a very short reply. 1.02. What is the ratio of the Total Labor Force (in %) of Belgium in 1992 to that in 1998?
Provide a short and direct response. 1.02. What is the ratio of the Total Labor Force (in %) of Estonia in 1992 to that in 1998?
Make the answer very short. 1.19. What is the ratio of the Total Labor Force (in %) of Qatar in 1992 to that in 1998?
Ensure brevity in your answer.  1.11. What is the ratio of the Total Labor Force (in %) in Armenia in 1992 to that in 1999?
Provide a succinct answer. 1.02. What is the ratio of the Total Labor Force (in %) of Belgium in 1992 to that in 1999?
Provide a succinct answer. 1.03. What is the ratio of the Total Labor Force (in %) of Estonia in 1992 to that in 1999?
Your response must be concise. 1.27. What is the ratio of the Total Labor Force (in %) in Qatar in 1992 to that in 1999?
Your response must be concise. 1.17. What is the ratio of the Total Labor Force (in %) of Armenia in 1993 to that in 1994?
Make the answer very short. 1. What is the ratio of the Total Labor Force (in %) in Belgium in 1993 to that in 1994?
Offer a terse response. 0.98. What is the ratio of the Total Labor Force (in %) of Estonia in 1993 to that in 1994?
Offer a terse response. 1.01. What is the ratio of the Total Labor Force (in %) in Armenia in 1993 to that in 1995?
Keep it short and to the point. 1. What is the ratio of the Total Labor Force (in %) in Belgium in 1993 to that in 1995?
Your response must be concise. 1.01. What is the ratio of the Total Labor Force (in %) in Estonia in 1993 to that in 1995?
Ensure brevity in your answer.  1.01. What is the ratio of the Total Labor Force (in %) in Qatar in 1993 to that in 1995?
Offer a very short reply. 0.98. What is the ratio of the Total Labor Force (in %) of Belgium in 1993 to that in 1996?
Keep it short and to the point. 1.01. What is the ratio of the Total Labor Force (in %) of Estonia in 1993 to that in 1996?
Offer a very short reply. 1.04. What is the ratio of the Total Labor Force (in %) of Qatar in 1993 to that in 1996?
Make the answer very short. 1.01. What is the ratio of the Total Labor Force (in %) in Armenia in 1993 to that in 1997?
Offer a terse response. 1. What is the ratio of the Total Labor Force (in %) of Belgium in 1993 to that in 1997?
Your answer should be very brief. 1.03. What is the ratio of the Total Labor Force (in %) in Estonia in 1993 to that in 1997?
Provide a succinct answer. 1.07. What is the ratio of the Total Labor Force (in %) of Qatar in 1993 to that in 1997?
Your answer should be very brief. 1.08. What is the ratio of the Total Labor Force (in %) of Armenia in 1993 to that in 1998?
Keep it short and to the point. 1.01. What is the ratio of the Total Labor Force (in %) in Estonia in 1993 to that in 1998?
Your answer should be very brief. 1.18. What is the ratio of the Total Labor Force (in %) in Qatar in 1993 to that in 1998?
Provide a succinct answer. 1.15. What is the ratio of the Total Labor Force (in %) of Armenia in 1993 to that in 1999?
Ensure brevity in your answer.  1.01. What is the ratio of the Total Labor Force (in %) in Belgium in 1993 to that in 1999?
Provide a succinct answer. 1. What is the ratio of the Total Labor Force (in %) in Estonia in 1993 to that in 1999?
Provide a succinct answer. 1.26. What is the ratio of the Total Labor Force (in %) in Qatar in 1993 to that in 1999?
Your response must be concise. 1.21. What is the ratio of the Total Labor Force (in %) in Belgium in 1994 to that in 1995?
Keep it short and to the point. 1.03. What is the ratio of the Total Labor Force (in %) in Estonia in 1994 to that in 1995?
Ensure brevity in your answer.  1.01. What is the ratio of the Total Labor Force (in %) in Qatar in 1994 to that in 1995?
Ensure brevity in your answer.  1. What is the ratio of the Total Labor Force (in %) of Armenia in 1994 to that in 1996?
Ensure brevity in your answer.  1. What is the ratio of the Total Labor Force (in %) in Belgium in 1994 to that in 1996?
Your answer should be very brief. 1.04. What is the ratio of the Total Labor Force (in %) of Estonia in 1994 to that in 1996?
Keep it short and to the point. 1.04. What is the ratio of the Total Labor Force (in %) of Qatar in 1994 to that in 1996?
Your response must be concise. 1.03. What is the ratio of the Total Labor Force (in %) in Armenia in 1994 to that in 1997?
Your answer should be compact. 1.01. What is the ratio of the Total Labor Force (in %) of Belgium in 1994 to that in 1997?
Your answer should be very brief. 1.05. What is the ratio of the Total Labor Force (in %) of Estonia in 1994 to that in 1997?
Offer a very short reply. 1.07. What is the ratio of the Total Labor Force (in %) of Qatar in 1994 to that in 1997?
Your answer should be compact. 1.1. What is the ratio of the Total Labor Force (in %) of Armenia in 1994 to that in 1998?
Make the answer very short. 1.01. What is the ratio of the Total Labor Force (in %) of Belgium in 1994 to that in 1998?
Provide a short and direct response. 1.02. What is the ratio of the Total Labor Force (in %) of Estonia in 1994 to that in 1998?
Provide a succinct answer. 1.18. What is the ratio of the Total Labor Force (in %) of Qatar in 1994 to that in 1998?
Your response must be concise. 1.18. What is the ratio of the Total Labor Force (in %) of Armenia in 1994 to that in 1999?
Provide a short and direct response. 1.02. What is the ratio of the Total Labor Force (in %) in Belgium in 1994 to that in 1999?
Ensure brevity in your answer.  1.03. What is the ratio of the Total Labor Force (in %) of Estonia in 1994 to that in 1999?
Provide a short and direct response. 1.26. What is the ratio of the Total Labor Force (in %) of Qatar in 1994 to that in 1999?
Your response must be concise. 1.24. What is the ratio of the Total Labor Force (in %) in Belgium in 1995 to that in 1996?
Keep it short and to the point. 1. What is the ratio of the Total Labor Force (in %) in Estonia in 1995 to that in 1996?
Give a very brief answer. 1.03. What is the ratio of the Total Labor Force (in %) of Qatar in 1995 to that in 1996?
Provide a short and direct response. 1.03. What is the ratio of the Total Labor Force (in %) of Belgium in 1995 to that in 1997?
Offer a very short reply. 1.02. What is the ratio of the Total Labor Force (in %) of Estonia in 1995 to that in 1997?
Your answer should be compact. 1.06. What is the ratio of the Total Labor Force (in %) in Qatar in 1995 to that in 1997?
Give a very brief answer. 1.1. What is the ratio of the Total Labor Force (in %) of Armenia in 1995 to that in 1998?
Keep it short and to the point. 1.01. What is the ratio of the Total Labor Force (in %) of Belgium in 1995 to that in 1998?
Give a very brief answer. 0.99. What is the ratio of the Total Labor Force (in %) in Estonia in 1995 to that in 1998?
Ensure brevity in your answer.  1.17. What is the ratio of the Total Labor Force (in %) of Qatar in 1995 to that in 1998?
Offer a very short reply. 1.18. What is the ratio of the Total Labor Force (in %) of Armenia in 1995 to that in 1999?
Ensure brevity in your answer.  1.02. What is the ratio of the Total Labor Force (in %) in Belgium in 1995 to that in 1999?
Provide a short and direct response. 0.99. What is the ratio of the Total Labor Force (in %) in Estonia in 1995 to that in 1999?
Offer a terse response. 1.25. What is the ratio of the Total Labor Force (in %) in Qatar in 1995 to that in 1999?
Provide a succinct answer. 1.24. What is the ratio of the Total Labor Force (in %) of Belgium in 1996 to that in 1997?
Your answer should be very brief. 1.02. What is the ratio of the Total Labor Force (in %) of Estonia in 1996 to that in 1997?
Make the answer very short. 1.03. What is the ratio of the Total Labor Force (in %) of Qatar in 1996 to that in 1997?
Provide a succinct answer. 1.07. What is the ratio of the Total Labor Force (in %) in Armenia in 1996 to that in 1998?
Provide a succinct answer. 1.01. What is the ratio of the Total Labor Force (in %) in Belgium in 1996 to that in 1998?
Make the answer very short. 0.98. What is the ratio of the Total Labor Force (in %) in Estonia in 1996 to that in 1998?
Keep it short and to the point. 1.14. What is the ratio of the Total Labor Force (in %) of Qatar in 1996 to that in 1998?
Offer a very short reply. 1.14. What is the ratio of the Total Labor Force (in %) in Armenia in 1996 to that in 1999?
Your answer should be very brief. 1.01. What is the ratio of the Total Labor Force (in %) in Belgium in 1996 to that in 1999?
Your response must be concise. 0.99. What is the ratio of the Total Labor Force (in %) of Estonia in 1996 to that in 1999?
Your answer should be very brief. 1.21. What is the ratio of the Total Labor Force (in %) of Qatar in 1996 to that in 1999?
Make the answer very short. 1.2. What is the ratio of the Total Labor Force (in %) in Armenia in 1997 to that in 1998?
Provide a short and direct response. 1.01. What is the ratio of the Total Labor Force (in %) of Belgium in 1997 to that in 1998?
Keep it short and to the point. 0.97. What is the ratio of the Total Labor Force (in %) in Estonia in 1997 to that in 1998?
Provide a succinct answer. 1.1. What is the ratio of the Total Labor Force (in %) in Qatar in 1997 to that in 1998?
Give a very brief answer. 1.07. What is the ratio of the Total Labor Force (in %) of Armenia in 1997 to that in 1999?
Make the answer very short. 1.01. What is the ratio of the Total Labor Force (in %) of Belgium in 1997 to that in 1999?
Ensure brevity in your answer.  0.97. What is the ratio of the Total Labor Force (in %) of Estonia in 1997 to that in 1999?
Ensure brevity in your answer.  1.18. What is the ratio of the Total Labor Force (in %) of Qatar in 1997 to that in 1999?
Provide a succinct answer. 1.12. What is the ratio of the Total Labor Force (in %) in Belgium in 1998 to that in 1999?
Give a very brief answer. 1.01. What is the ratio of the Total Labor Force (in %) in Estonia in 1998 to that in 1999?
Make the answer very short. 1.07. What is the ratio of the Total Labor Force (in %) in Qatar in 1998 to that in 1999?
Make the answer very short. 1.05. What is the difference between the highest and the second highest Total Labor Force (in %) of Armenia?
Provide a succinct answer. 0.3. What is the difference between the highest and the second highest Total Labor Force (in %) of Estonia?
Give a very brief answer. 0.3. What is the difference between the highest and the lowest Total Labor Force (in %) in Armenia?
Provide a short and direct response. 1.3. What is the difference between the highest and the lowest Total Labor Force (in %) in Belgium?
Your answer should be very brief. 1.9. What is the difference between the highest and the lowest Total Labor Force (in %) in Qatar?
Give a very brief answer. 14.9. 